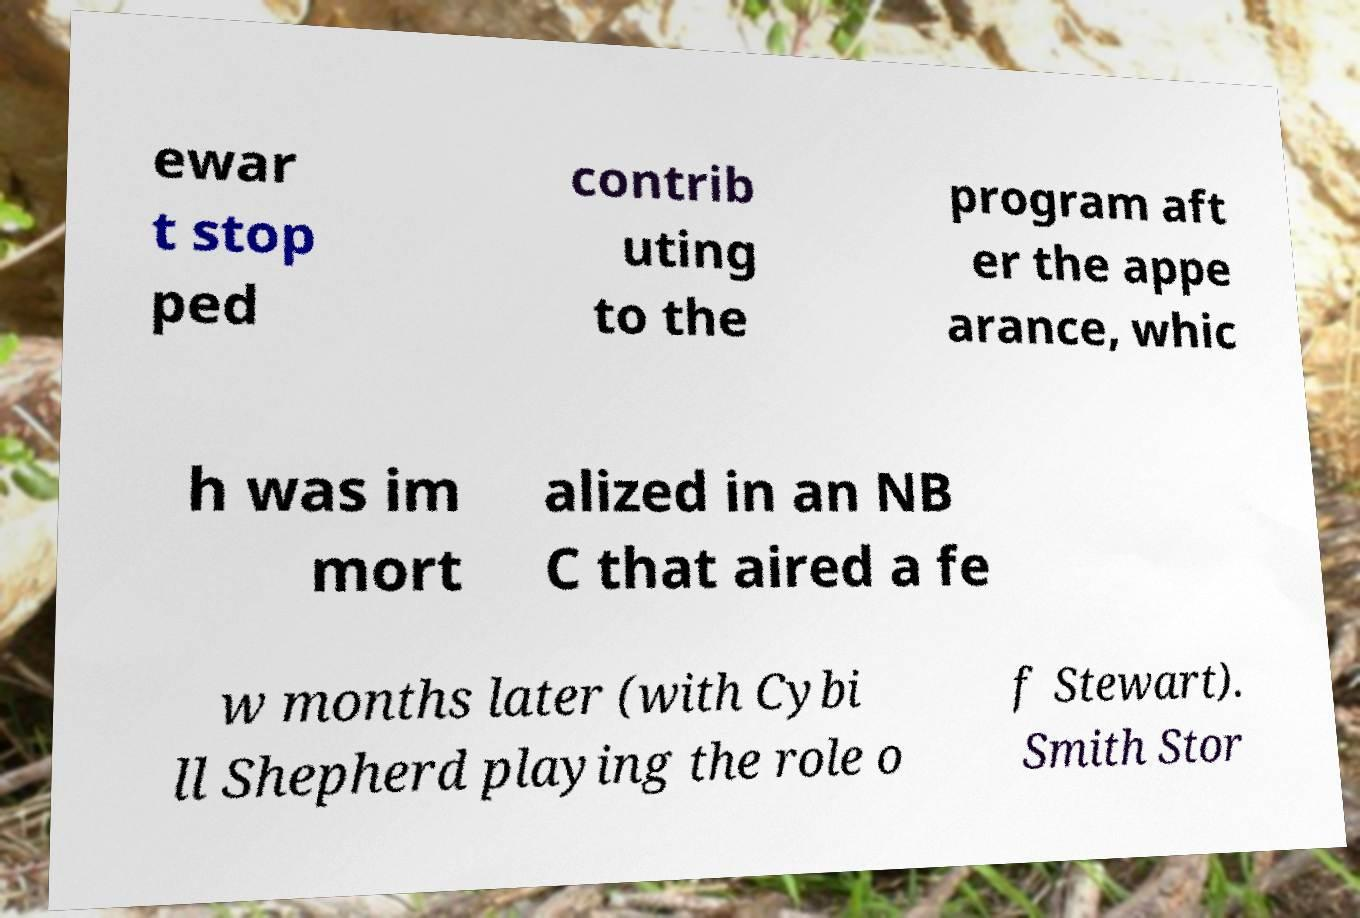There's text embedded in this image that I need extracted. Can you transcribe it verbatim? ewar t stop ped contrib uting to the program aft er the appe arance, whic h was im mort alized in an NB C that aired a fe w months later (with Cybi ll Shepherd playing the role o f Stewart). Smith Stor 